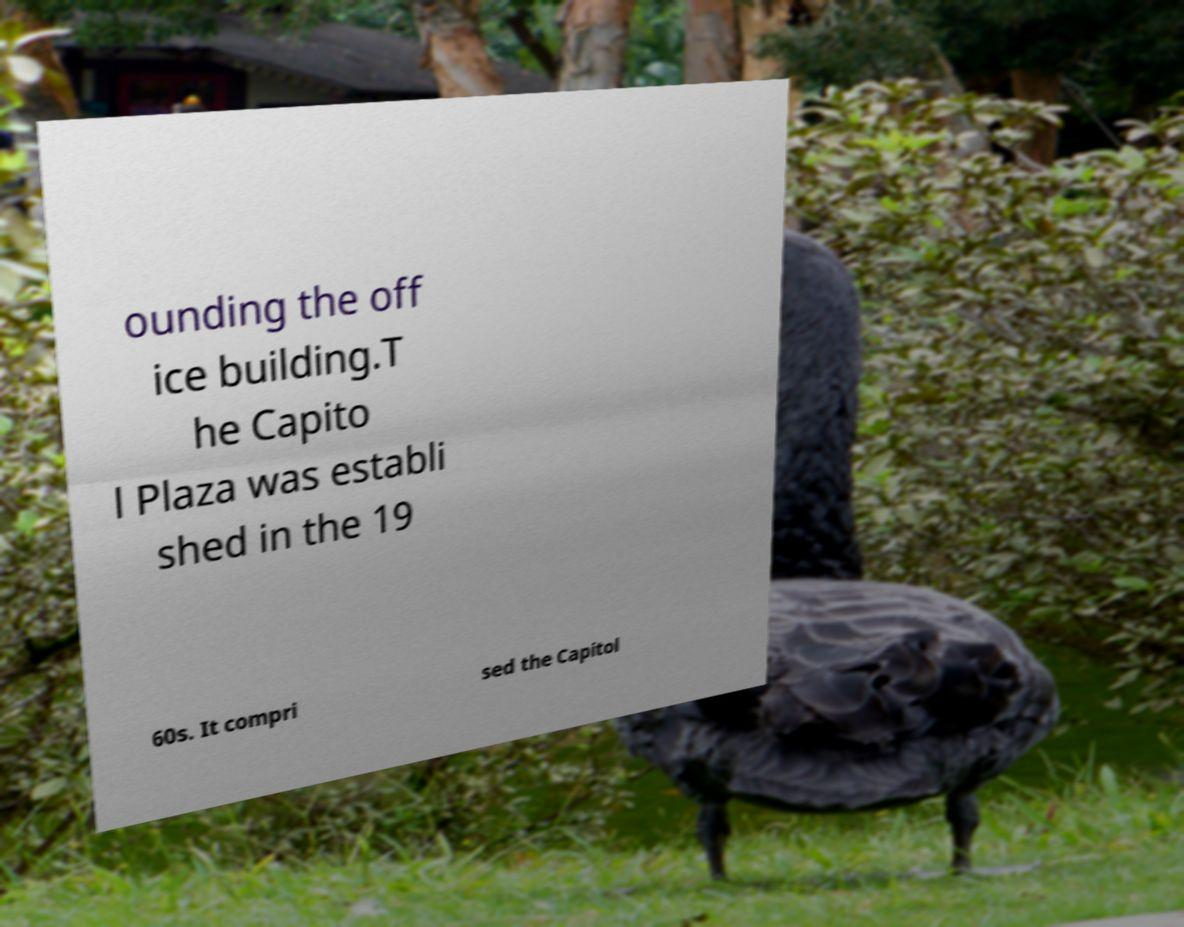I need the written content from this picture converted into text. Can you do that? ounding the off ice building.T he Capito l Plaza was establi shed in the 19 60s. It compri sed the Capitol 